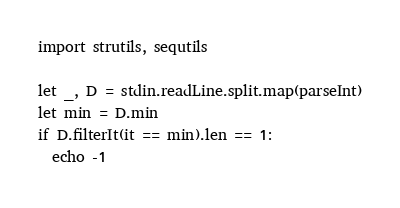Convert code to text. <code><loc_0><loc_0><loc_500><loc_500><_Nim_>import strutils, sequtils

let _, D = stdin.readLine.split.map(parseInt)
let min = D.min
if D.filterIt(it == min).len == 1:
  echo -1
</code> 